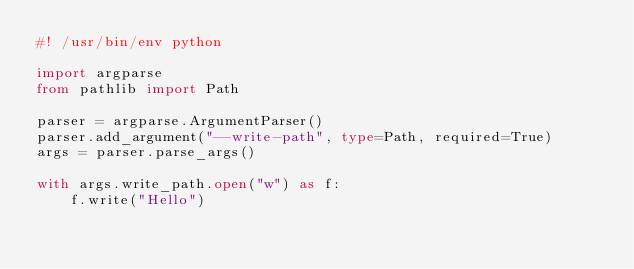Convert code to text. <code><loc_0><loc_0><loc_500><loc_500><_Python_>#! /usr/bin/env python

import argparse
from pathlib import Path

parser = argparse.ArgumentParser()
parser.add_argument("--write-path", type=Path, required=True)
args = parser.parse_args()

with args.write_path.open("w") as f:
    f.write("Hello")
</code> 